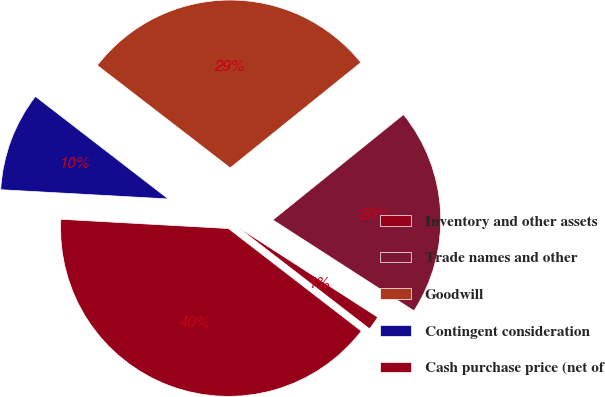Convert chart to OTSL. <chart><loc_0><loc_0><loc_500><loc_500><pie_chart><fcel>Inventory and other assets<fcel>Trade names and other<fcel>Goodwill<fcel>Contingent consideration<fcel>Cash purchase price (net of<nl><fcel>1.35%<fcel>19.91%<fcel>28.74%<fcel>9.58%<fcel>40.42%<nl></chart> 